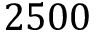<formula> <loc_0><loc_0><loc_500><loc_500>2 5 0 0</formula> 